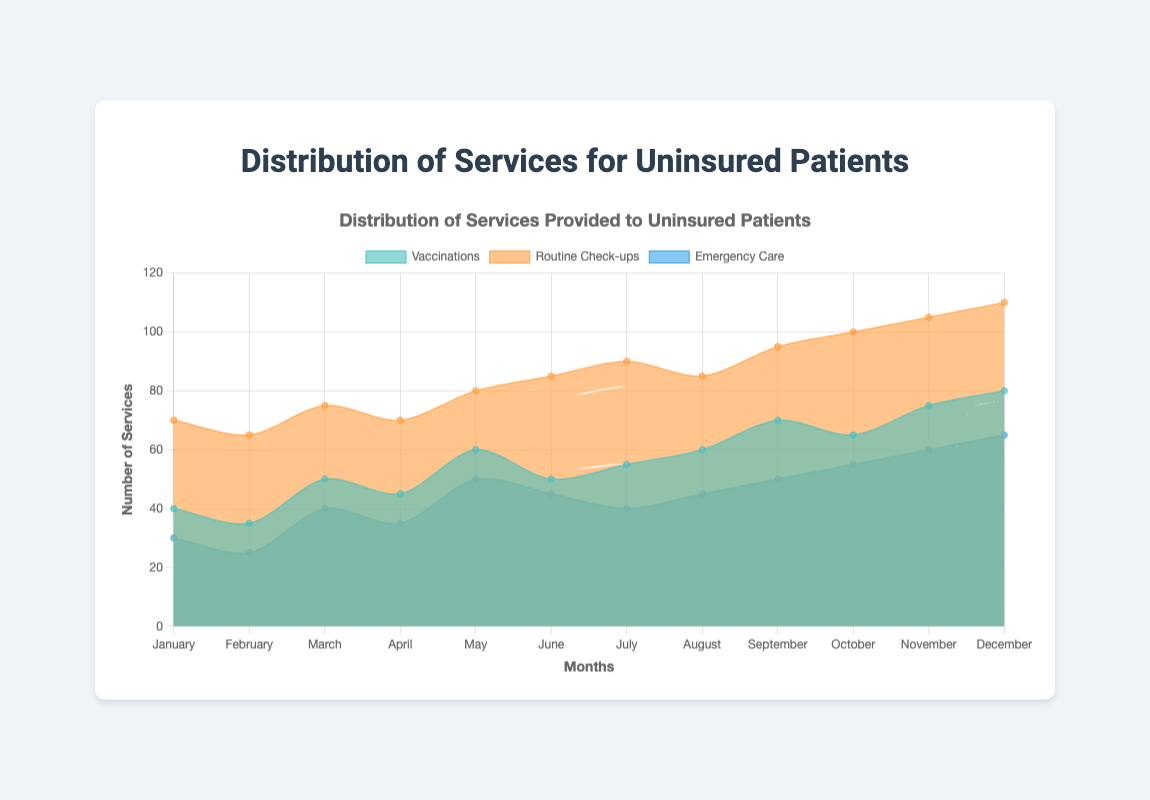What is the title of the chart? The title is located at the top center of the chart and serves as a brief description of the overall content. By reading the title, one can understand what the chart represents.
Answer: Distribution of Services Provided to Uninsured Patients During which month were the most routine check-ups provided? By examining the line representing routine check-ups and finding the highest point on the y-axis, we can see which month had the peak value for routine check-ups.
Answer: December How many vaccinations were given in the month of May? Locate the May data point on the x-axis and look at the value for vaccinations plotted on the area chart.
Answer: 60 Which service experienced the largest increase in the number of cases from January to December? Compare the starting and ending values for each service and calculate the difference.
Answer: Routine Check-ups How do the number of vaccinations in August compare to the number of vaccinations in July? Check the y-axis values for the data points corresponding to vaccinations in July and August and compare them.
Answer: 60 vs. 55 Calculate the average number of emergency care cases provided over the year. Sum up all the monthly values of emergency care and divide by the total number of months (12). (30+25+40+35+50+45+40+45+50+55+60+65)/12 = 45.416... ~ 45.4
Answer: 45.4 In which month was the lowest number of emergency care cases provided? Identify the lowest data point along the y-axis for emergency care cases.
Answer: February What is the total number of vaccinations and routine check-ups provided in October? Add the number of vaccinations and routine check-ups provided in October. (65+100)
Answer: 165 Compare the trend of vaccinations to routine check-ups over the first half of the year. What do you observe? By examining the trend from January to June for both services, observe the general movement of the lines. Routine check-ups gradually increase, while vaccinations show a more fluctuating pattern.
Answer: Routine check-ups increase steadily, vaccinations fluctuate Between which months was the increase in the number of emergency care services the most significant? Calculate the monthly differences and identify the largest positive change. From February to March, the change is (40-25) = 15.
Answer: February to March 